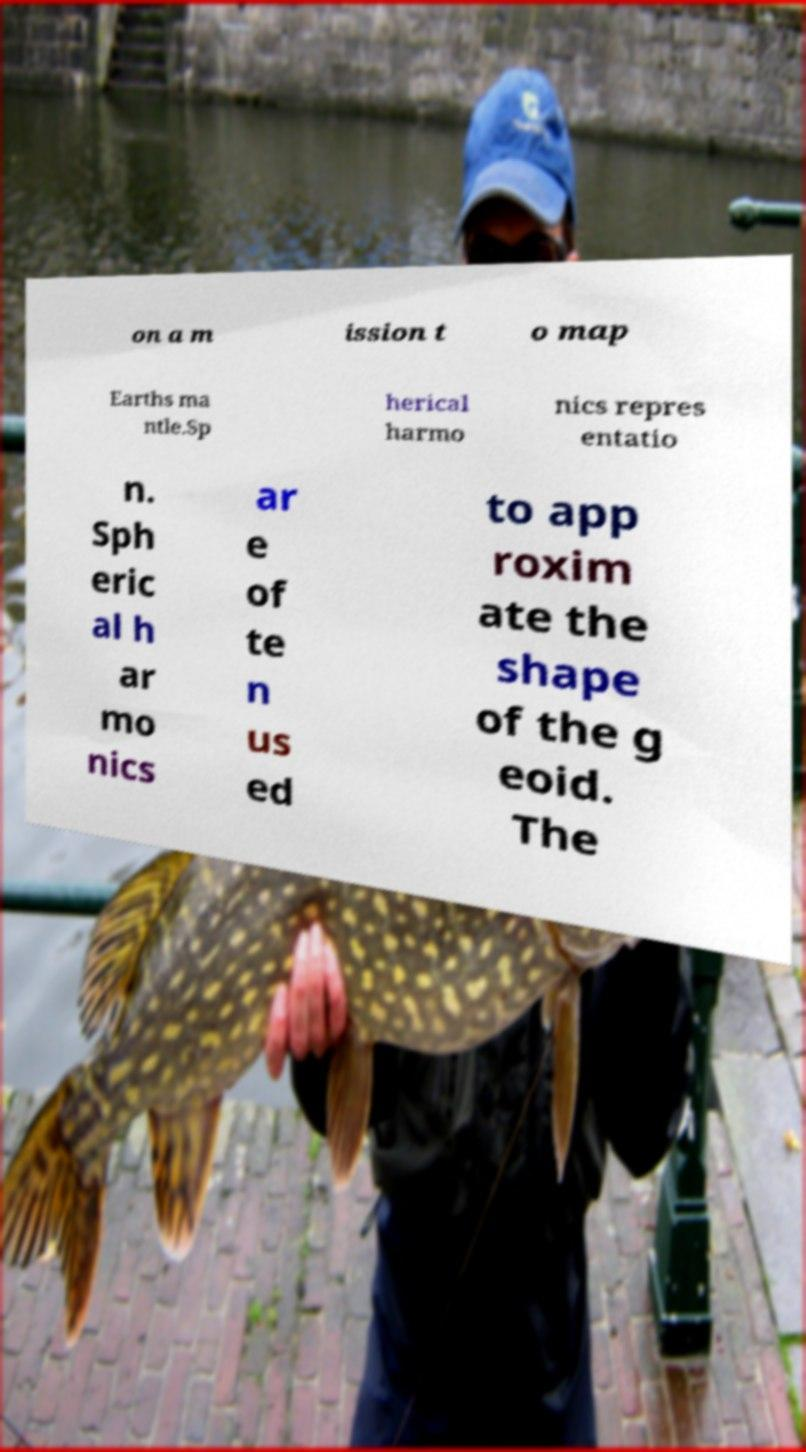Can you read and provide the text displayed in the image?This photo seems to have some interesting text. Can you extract and type it out for me? on a m ission t o map Earths ma ntle.Sp herical harmo nics repres entatio n. Sph eric al h ar mo nics ar e of te n us ed to app roxim ate the shape of the g eoid. The 